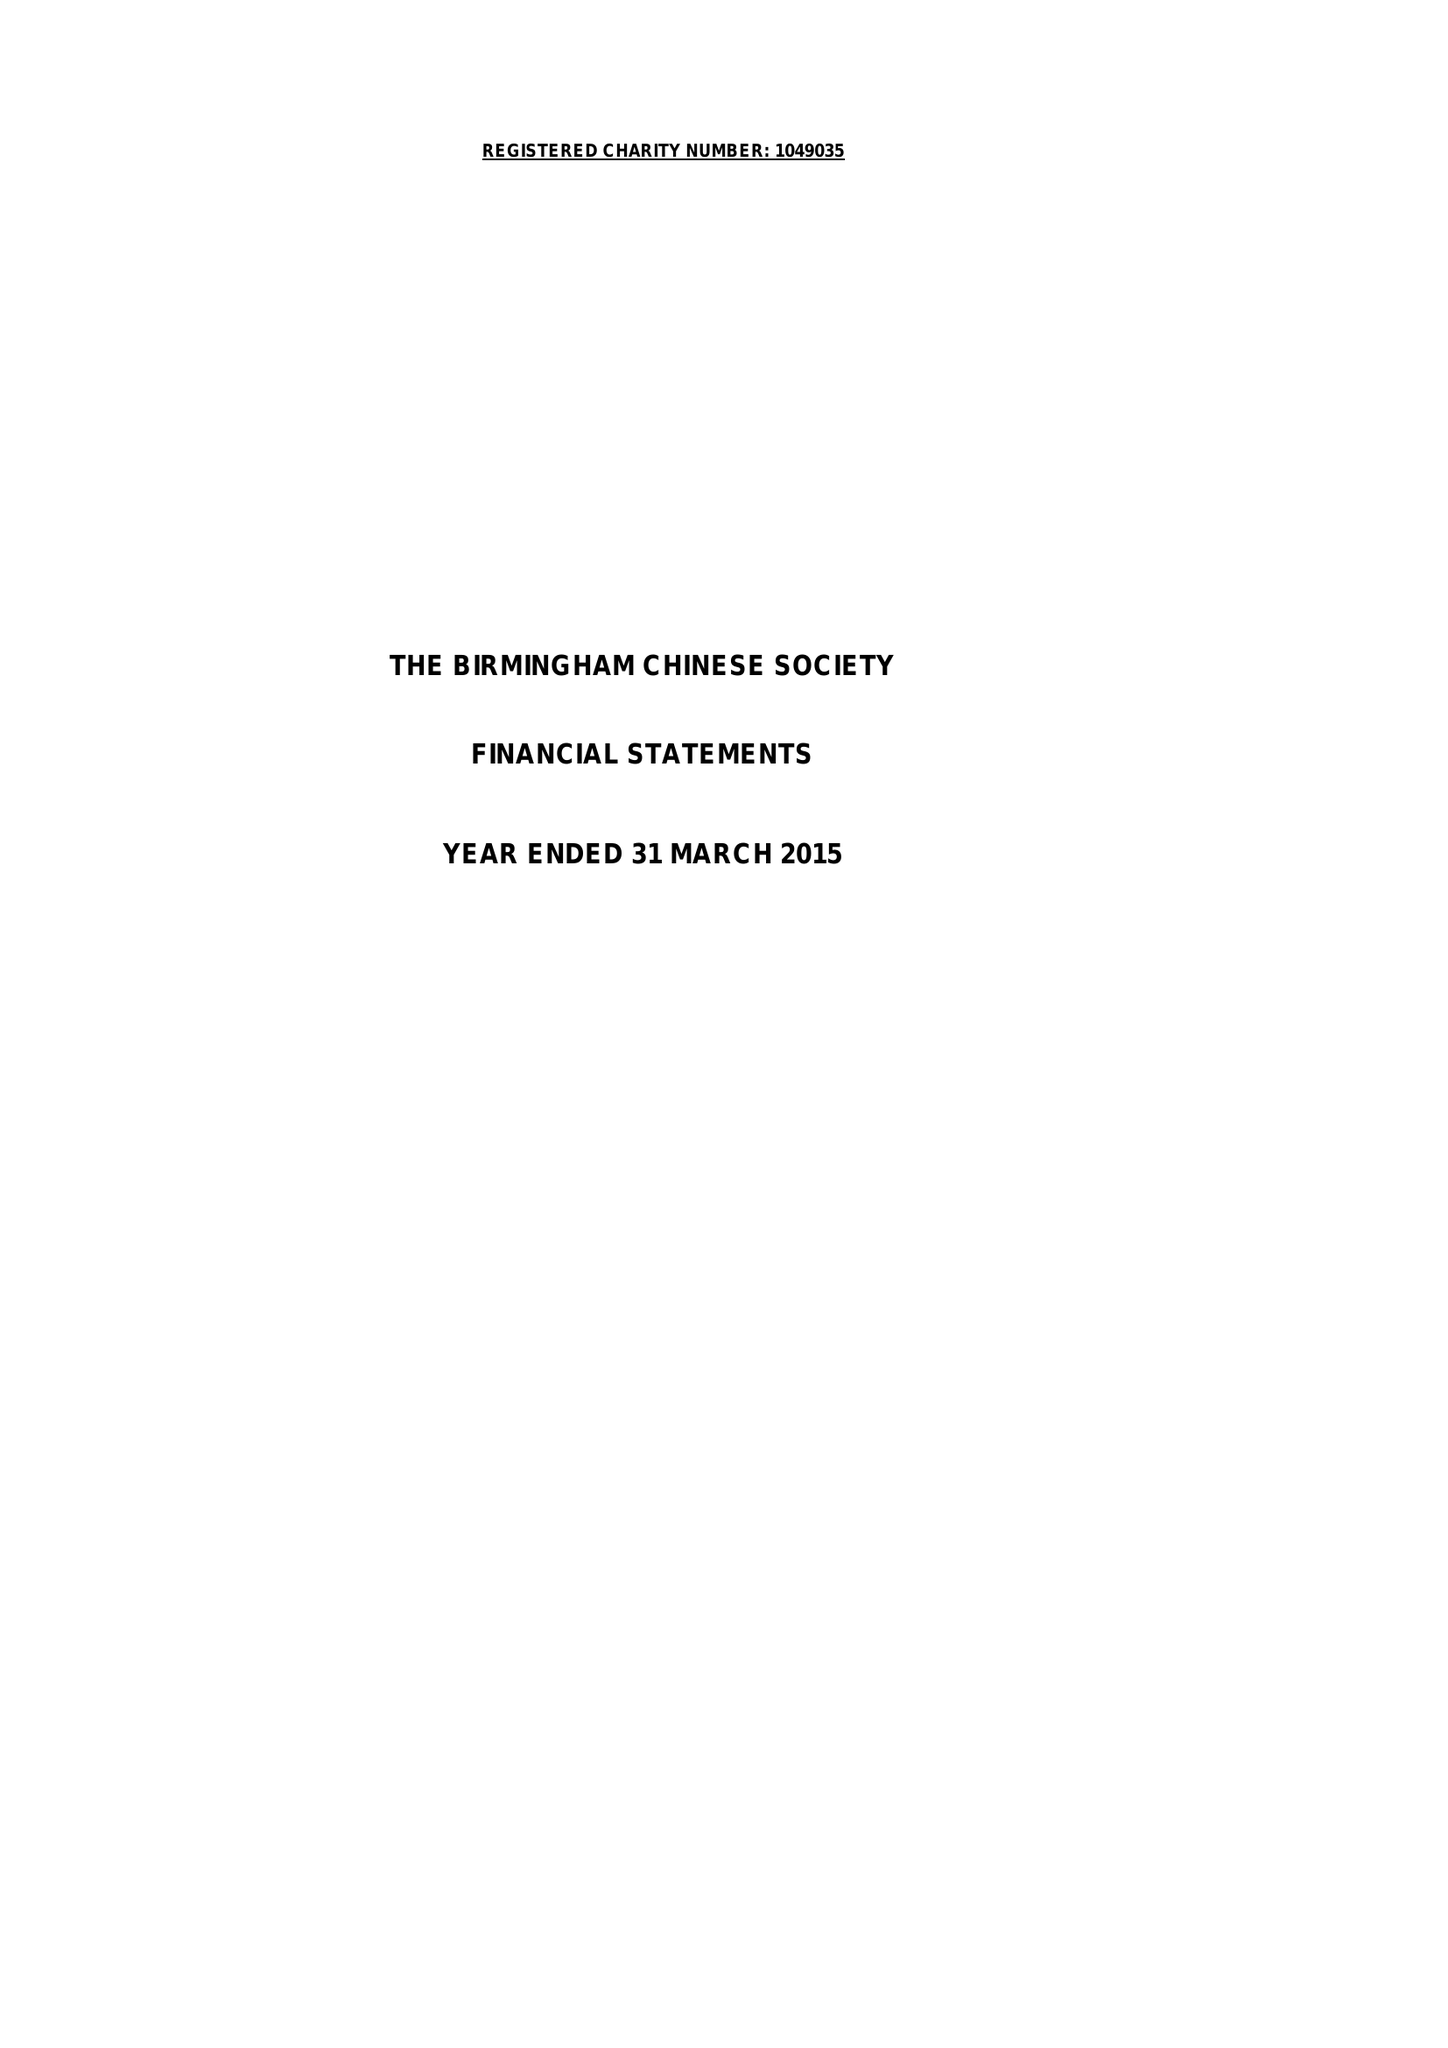What is the value for the address__post_town?
Answer the question using a single word or phrase. BIRMINGHAM 